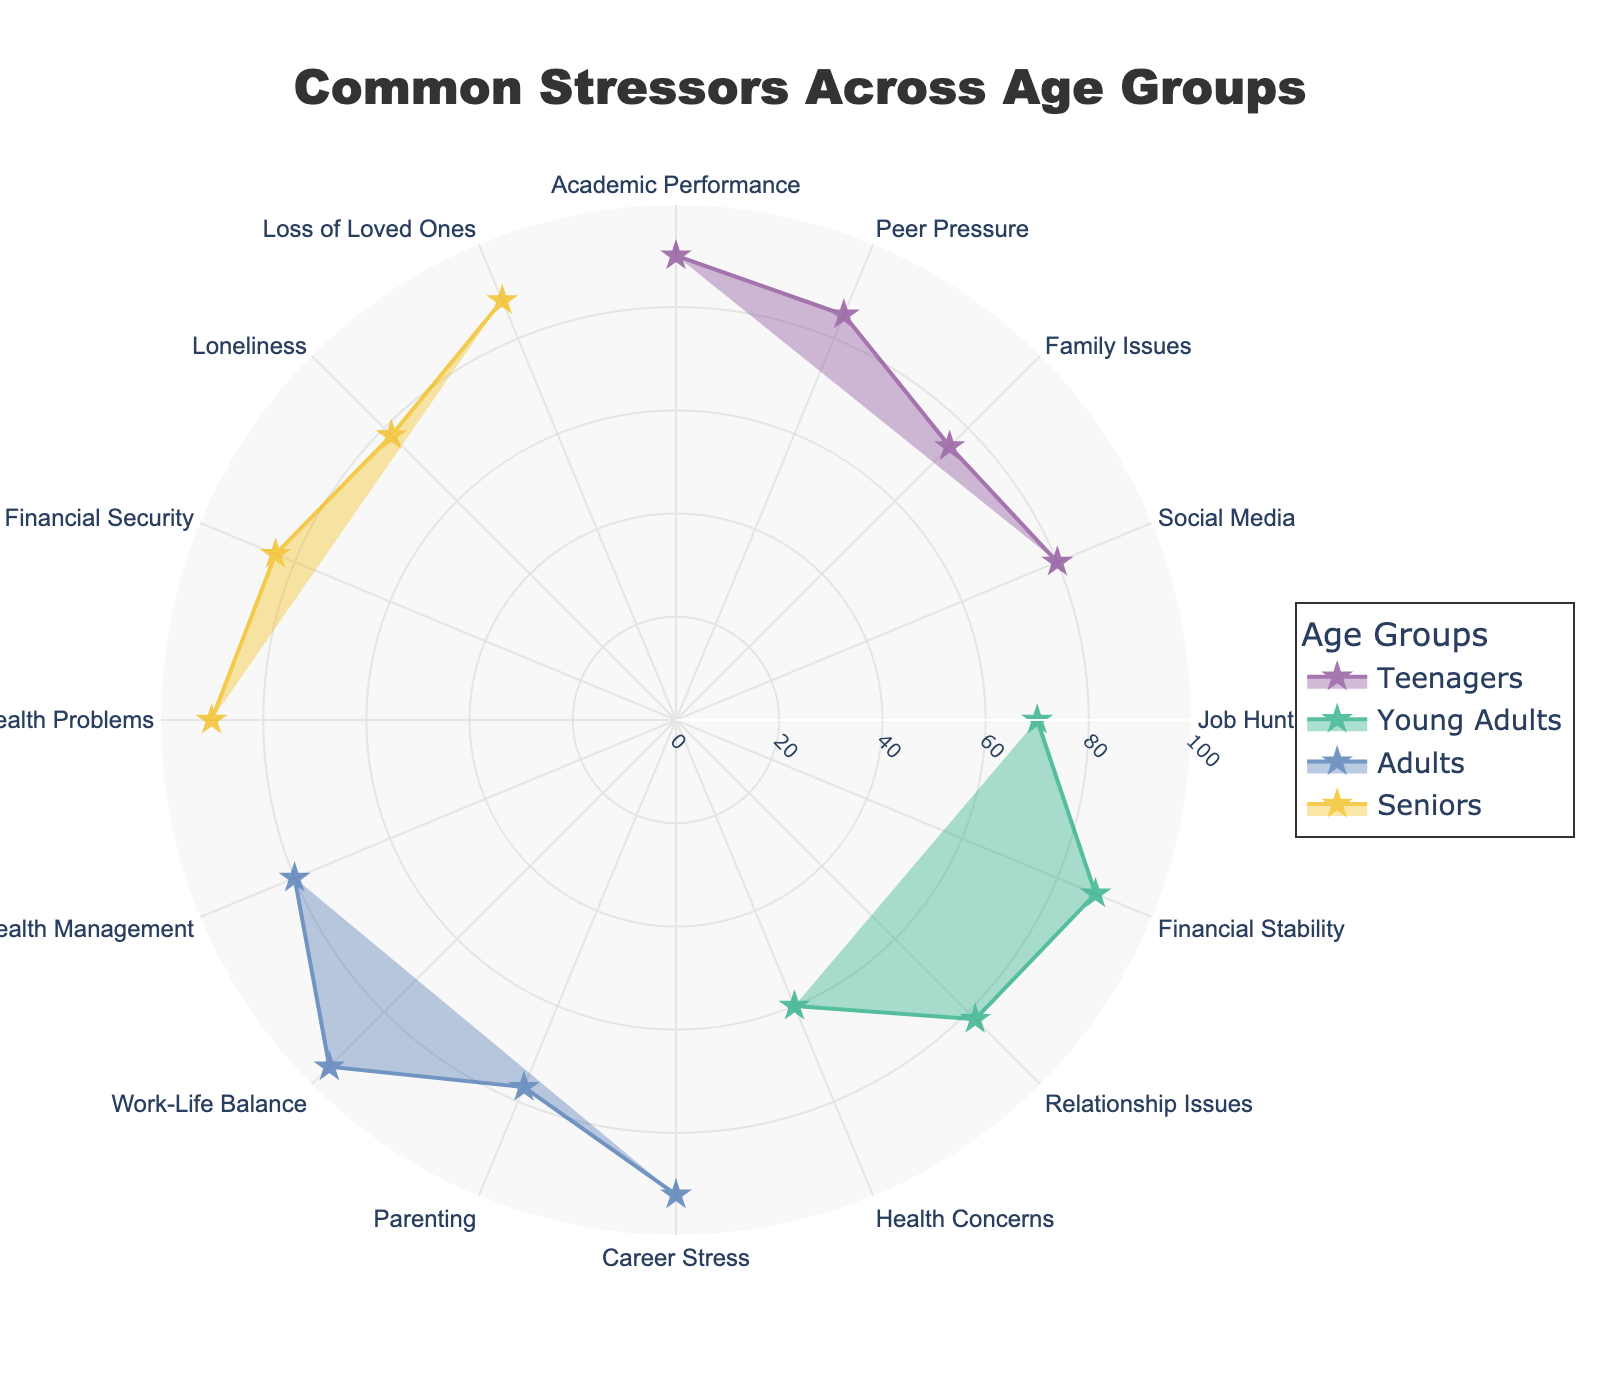what is the title of the chart? The title is found at the top center of the chart, usually in larger and bolder text to distinguish it from other elements.
Answer: Common Stressors Across Age Groups Which age group reports the highest frequency stressor, and what is it? Look for the highest point in the respective radial axis for each age group, and identify the corresponding stressor. Adults report the highest frequency stressor with Work-Life Balance having a frequency of 95.
Answer: Adults, Work-Life Balance What is the average frequency of stressors reported by Young Adults? Calculate the sum of the frequencies for Young Adults and divide by the number of stressors. Young Adult stressor frequencies are 70, 88, 82, and 60. (70+88+82+60) / 4 = 300 / 4 = 75.
Answer: 75 Among stressors reported by Seniors, which one is least common, and what's its frequency? Among the stressors listed under the Seniors category, find the one with the lowest number on the radial axis. Loneliness is the least common stressor for Seniors with a frequency of 78.
Answer: Loneliness, 78 How do the frequencies of Academic Performance and Social Media stressors in Teenagers compare? Identify the frequencies of both stressors for Teenagers and compare them directly. Academic Performance has a frequency of 90, and Social Media has a frequency of 80, so Academic Performance is higher.
Answer: Academic Performance is higher by 10 What is the combined frequency of Career Stress, Parenting, and Health Management for Adults? Add the frequencies of Career Stress, Parenting, and Health Management as reported by Adults. The frequencies are 92, 77, and 80 respectively. So, 92 + 77 + 80 = 249.
Answer: 249 Which stressor shows the smallest frequency for Young Adults, and what is its value? Among the stressors listed for Young Adults, identify the smallest value in the radial axis. Health Concerns has the smallest frequency of 60.
Answer: Health Concerns, 60 Which age group has the most variation in stressor frequencies, and how can you tell? Calculate the range (difference between max and min frequencies) for each age group and compare them. Teenagers: 90 - 75 = 15, Young Adults: 88 - 60 = 28, Adults: 95 - 77 = 18, Seniors: 90 - 78 = 12. Young Adults have the greatest variation (28).
Answer: Young Adults What's the total number of unique stressors mentioned across all age groups? Identify unique labels on the angular axis and count them. Since stressors like "Health Concerns" and "Health Problems" are considered different based on provided data set, there are 14 unique stressors.
Answer: 14 